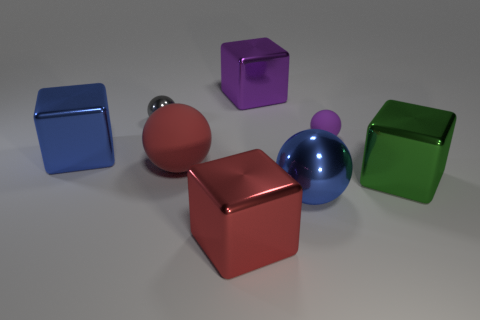What is the size of the other red object that is the same shape as the tiny shiny object?
Make the answer very short. Large. Does the green shiny thing that is behind the red block have the same shape as the tiny rubber thing?
Make the answer very short. No. There is a big thing on the right side of the tiny purple rubber object; what color is it?
Provide a short and direct response. Green. What number of other objects are there of the same size as the red matte ball?
Keep it short and to the point. 5. Are there the same number of large blue metal cubes to the right of the large purple thing and tiny blue cylinders?
Your answer should be compact. Yes. How many big balls are made of the same material as the tiny purple sphere?
Make the answer very short. 1. The big ball that is made of the same material as the tiny gray sphere is what color?
Ensure brevity in your answer.  Blue. Do the large matte object and the gray shiny thing have the same shape?
Give a very brief answer. Yes. There is a thing on the right side of the tiny sphere on the right side of the big purple thing; are there any objects behind it?
Ensure brevity in your answer.  Yes. What number of spheres have the same color as the small metal thing?
Provide a succinct answer. 0. 